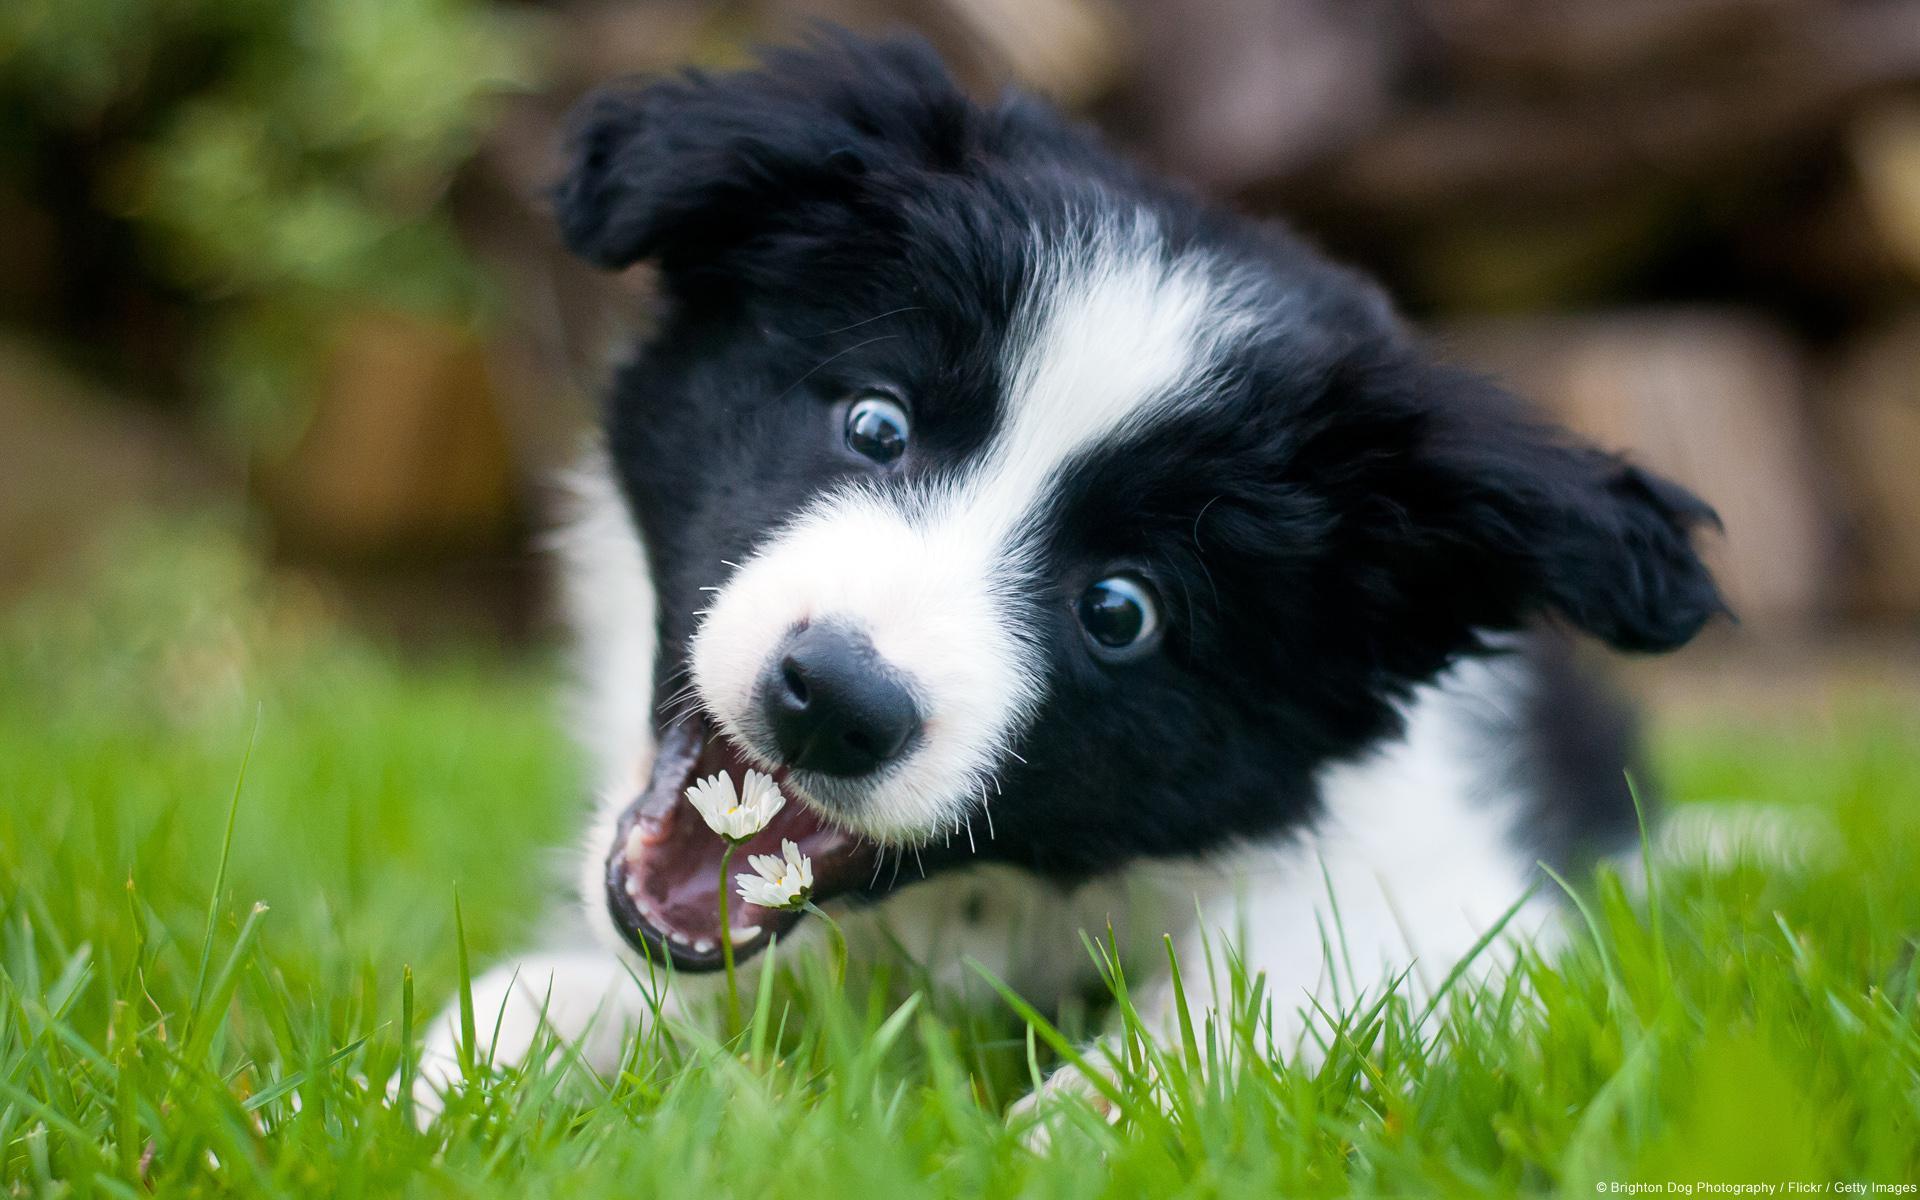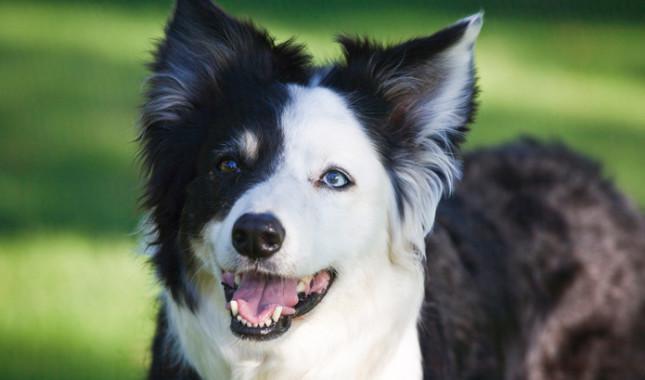The first image is the image on the left, the second image is the image on the right. For the images shown, is this caption "A dog in one image has one white eye and one black eye." true? Answer yes or no. Yes. 